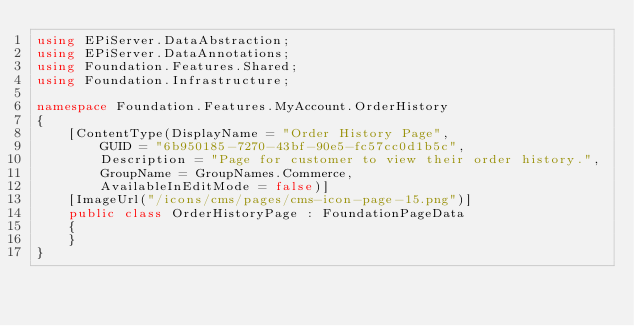<code> <loc_0><loc_0><loc_500><loc_500><_C#_>using EPiServer.DataAbstraction;
using EPiServer.DataAnnotations;
using Foundation.Features.Shared;
using Foundation.Infrastructure;

namespace Foundation.Features.MyAccount.OrderHistory
{
    [ContentType(DisplayName = "Order History Page",
        GUID = "6b950185-7270-43bf-90e5-fc57cc0d1b5c",
        Description = "Page for customer to view their order history.",
        GroupName = GroupNames.Commerce,
        AvailableInEditMode = false)]
    [ImageUrl("/icons/cms/pages/cms-icon-page-15.png")]
    public class OrderHistoryPage : FoundationPageData
    {
    }
}</code> 